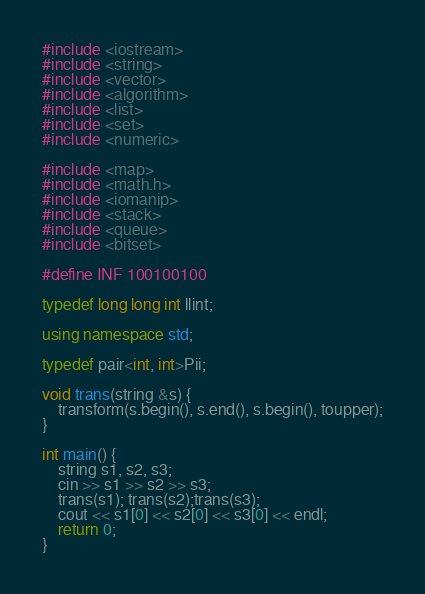<code> <loc_0><loc_0><loc_500><loc_500><_C++_>#include <iostream>
#include <string>
#include <vector>
#include <algorithm>
#include <list>
#include <set>
#include <numeric>

#include <map>
#include <math.h>
#include <iomanip>
#include <stack>
#include <queue>
#include <bitset>

#define INF 100100100

typedef long long int llint;

using namespace std;

typedef pair<int, int>Pii;

void trans(string &s) {
	transform(s.begin(), s.end(), s.begin(), toupper);
}

int main() {
	string s1, s2, s3;
	cin >> s1 >> s2 >> s3;
	trans(s1); trans(s2);trans(s3);
	cout << s1[0] << s2[0] << s3[0] << endl;
	return 0;
}</code> 